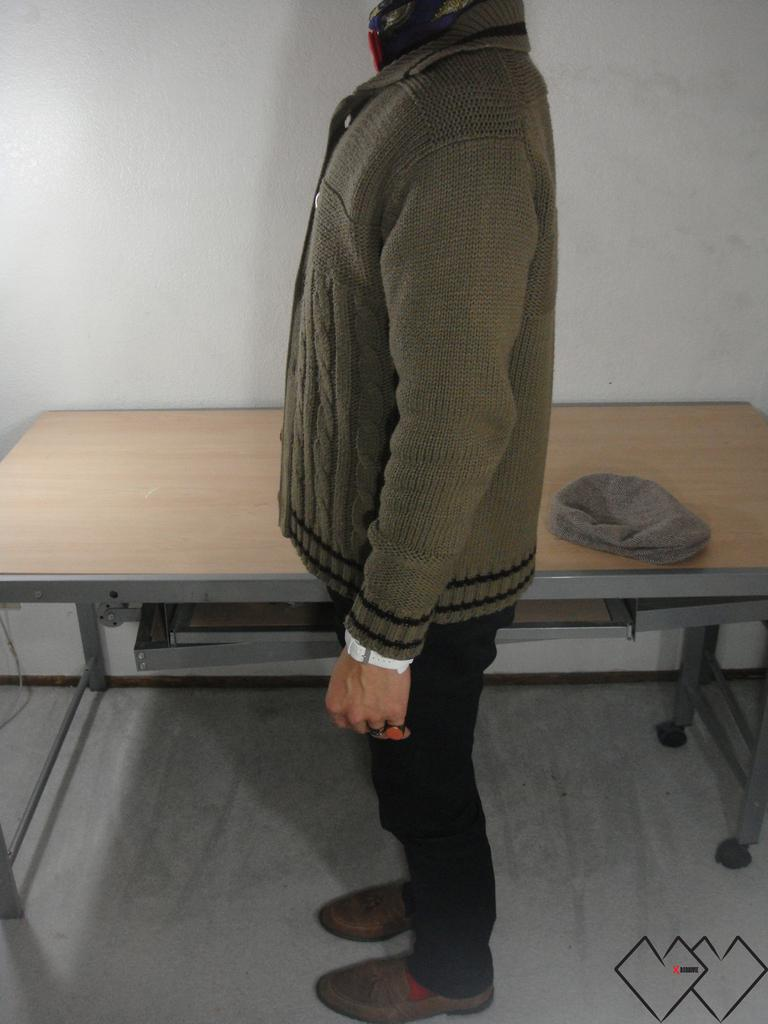Where was the image taken? The image was taken inside a room. Can you describe the man in the image? The man in the image is wearing a green jacket. What is the man doing in the image? The man is standing beside a table. What color is the wall behind the man? The wall behind the man is white. What object is on the table in the image? There is a grey color cap on the table. What type of worm can be seen crawling on the man's jacket in the image? There is no worm present on the man's jacket in the image. What position does the man hold in the company, as indicated by the image? The image does not provide information about the man's position or role in a company. 